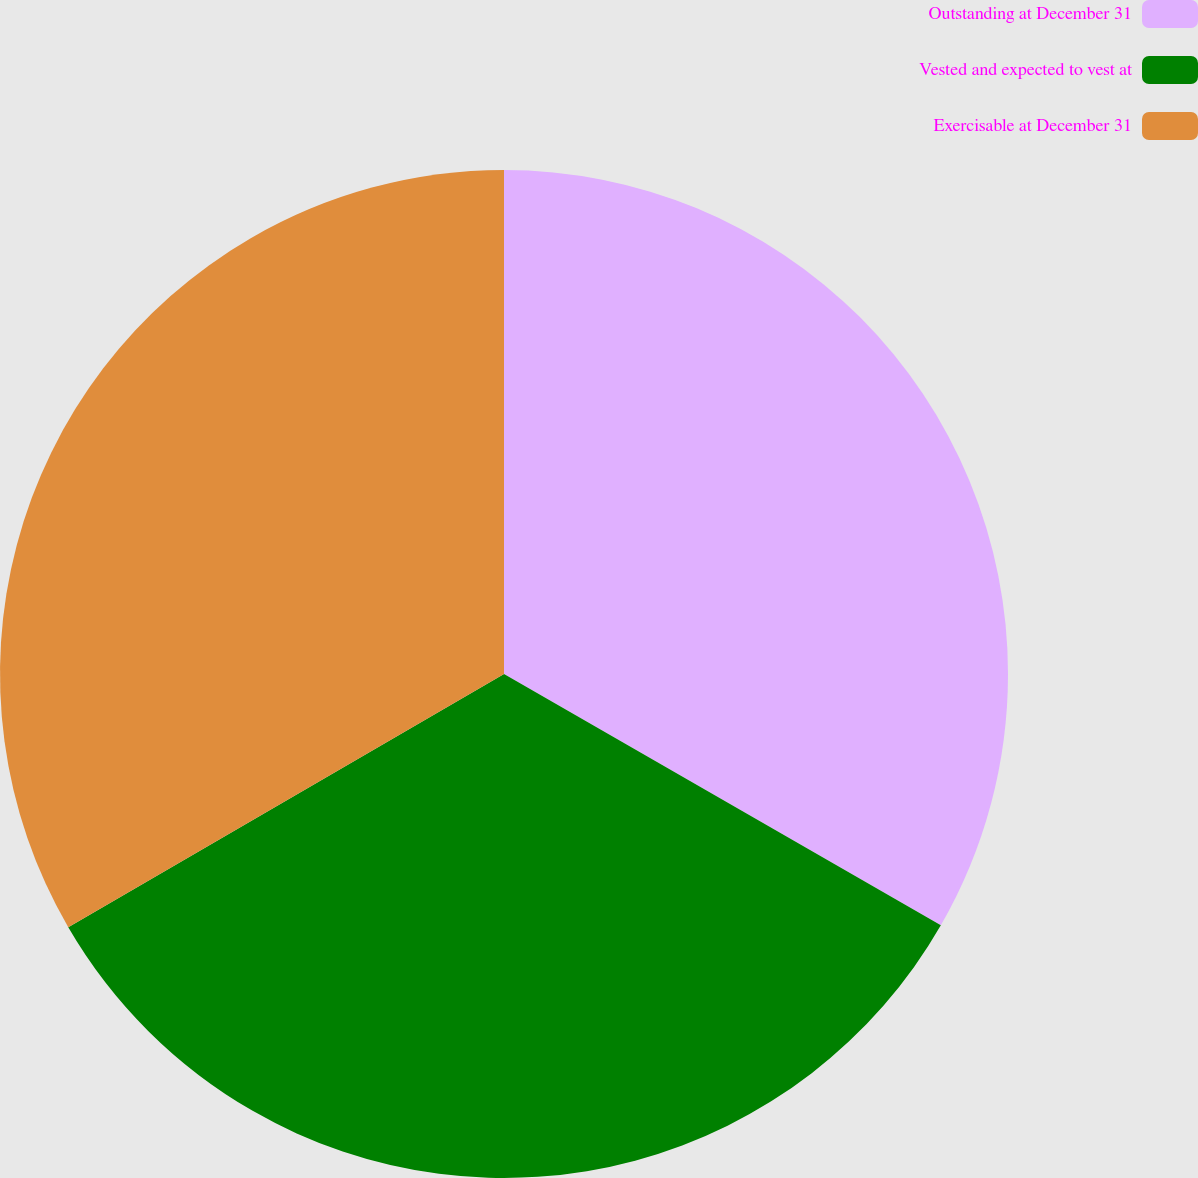Convert chart to OTSL. <chart><loc_0><loc_0><loc_500><loc_500><pie_chart><fcel>Outstanding at December 31<fcel>Vested and expected to vest at<fcel>Exercisable at December 31<nl><fcel>33.31%<fcel>33.31%<fcel>33.38%<nl></chart> 